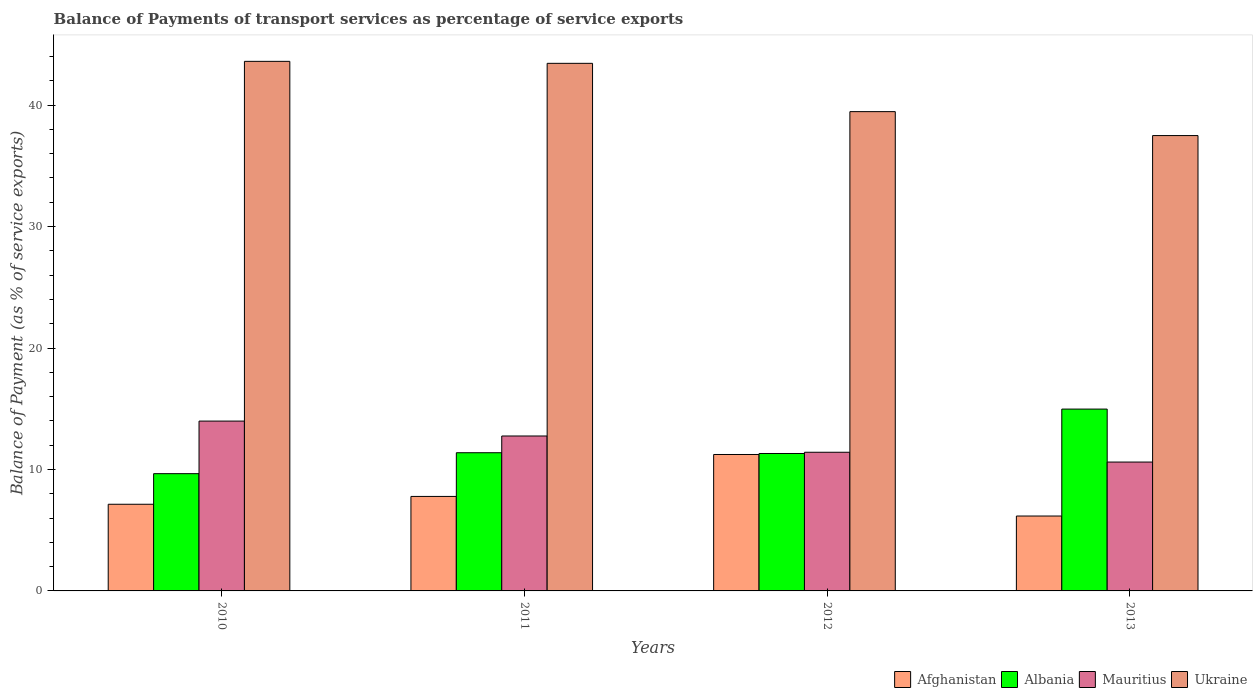How many groups of bars are there?
Offer a terse response. 4. How many bars are there on the 4th tick from the right?
Ensure brevity in your answer.  4. In how many cases, is the number of bars for a given year not equal to the number of legend labels?
Your answer should be compact. 0. What is the balance of payments of transport services in Ukraine in 2011?
Your answer should be compact. 43.44. Across all years, what is the maximum balance of payments of transport services in Mauritius?
Provide a short and direct response. 13.98. Across all years, what is the minimum balance of payments of transport services in Ukraine?
Provide a succinct answer. 37.49. In which year was the balance of payments of transport services in Mauritius minimum?
Give a very brief answer. 2013. What is the total balance of payments of transport services in Afghanistan in the graph?
Your response must be concise. 32.32. What is the difference between the balance of payments of transport services in Mauritius in 2010 and that in 2013?
Offer a very short reply. 3.37. What is the difference between the balance of payments of transport services in Afghanistan in 2010 and the balance of payments of transport services in Ukraine in 2012?
Offer a very short reply. -32.33. What is the average balance of payments of transport services in Mauritius per year?
Provide a succinct answer. 12.19. In the year 2011, what is the difference between the balance of payments of transport services in Albania and balance of payments of transport services in Mauritius?
Keep it short and to the point. -1.38. What is the ratio of the balance of payments of transport services in Afghanistan in 2011 to that in 2013?
Give a very brief answer. 1.26. Is the balance of payments of transport services in Afghanistan in 2010 less than that in 2012?
Offer a very short reply. Yes. What is the difference between the highest and the second highest balance of payments of transport services in Afghanistan?
Provide a succinct answer. 3.45. What is the difference between the highest and the lowest balance of payments of transport services in Albania?
Your answer should be very brief. 5.32. In how many years, is the balance of payments of transport services in Afghanistan greater than the average balance of payments of transport services in Afghanistan taken over all years?
Provide a short and direct response. 1. Is it the case that in every year, the sum of the balance of payments of transport services in Mauritius and balance of payments of transport services in Ukraine is greater than the sum of balance of payments of transport services in Afghanistan and balance of payments of transport services in Albania?
Make the answer very short. Yes. What does the 3rd bar from the left in 2012 represents?
Offer a very short reply. Mauritius. What does the 1st bar from the right in 2010 represents?
Your answer should be compact. Ukraine. How many bars are there?
Keep it short and to the point. 16. Are all the bars in the graph horizontal?
Ensure brevity in your answer.  No. How many years are there in the graph?
Your answer should be very brief. 4. Does the graph contain any zero values?
Offer a terse response. No. Where does the legend appear in the graph?
Your response must be concise. Bottom right. How many legend labels are there?
Ensure brevity in your answer.  4. How are the legend labels stacked?
Your response must be concise. Horizontal. What is the title of the graph?
Provide a succinct answer. Balance of Payments of transport services as percentage of service exports. What is the label or title of the Y-axis?
Your answer should be very brief. Balance of Payment (as % of service exports). What is the Balance of Payment (as % of service exports) of Afghanistan in 2010?
Your response must be concise. 7.14. What is the Balance of Payment (as % of service exports) in Albania in 2010?
Offer a terse response. 9.65. What is the Balance of Payment (as % of service exports) of Mauritius in 2010?
Offer a very short reply. 13.98. What is the Balance of Payment (as % of service exports) of Ukraine in 2010?
Offer a very short reply. 43.6. What is the Balance of Payment (as % of service exports) of Afghanistan in 2011?
Offer a very short reply. 7.78. What is the Balance of Payment (as % of service exports) of Albania in 2011?
Provide a short and direct response. 11.38. What is the Balance of Payment (as % of service exports) of Mauritius in 2011?
Ensure brevity in your answer.  12.76. What is the Balance of Payment (as % of service exports) in Ukraine in 2011?
Keep it short and to the point. 43.44. What is the Balance of Payment (as % of service exports) in Afghanistan in 2012?
Ensure brevity in your answer.  11.23. What is the Balance of Payment (as % of service exports) of Albania in 2012?
Ensure brevity in your answer.  11.31. What is the Balance of Payment (as % of service exports) in Mauritius in 2012?
Keep it short and to the point. 11.42. What is the Balance of Payment (as % of service exports) in Ukraine in 2012?
Provide a succinct answer. 39.46. What is the Balance of Payment (as % of service exports) of Afghanistan in 2013?
Give a very brief answer. 6.17. What is the Balance of Payment (as % of service exports) of Albania in 2013?
Provide a short and direct response. 14.97. What is the Balance of Payment (as % of service exports) of Mauritius in 2013?
Offer a very short reply. 10.61. What is the Balance of Payment (as % of service exports) of Ukraine in 2013?
Make the answer very short. 37.49. Across all years, what is the maximum Balance of Payment (as % of service exports) in Afghanistan?
Provide a succinct answer. 11.23. Across all years, what is the maximum Balance of Payment (as % of service exports) of Albania?
Keep it short and to the point. 14.97. Across all years, what is the maximum Balance of Payment (as % of service exports) in Mauritius?
Offer a terse response. 13.98. Across all years, what is the maximum Balance of Payment (as % of service exports) of Ukraine?
Offer a terse response. 43.6. Across all years, what is the minimum Balance of Payment (as % of service exports) of Afghanistan?
Offer a terse response. 6.17. Across all years, what is the minimum Balance of Payment (as % of service exports) of Albania?
Offer a terse response. 9.65. Across all years, what is the minimum Balance of Payment (as % of service exports) of Mauritius?
Offer a very short reply. 10.61. Across all years, what is the minimum Balance of Payment (as % of service exports) of Ukraine?
Keep it short and to the point. 37.49. What is the total Balance of Payment (as % of service exports) in Afghanistan in the graph?
Your response must be concise. 32.32. What is the total Balance of Payment (as % of service exports) of Albania in the graph?
Offer a very short reply. 47.32. What is the total Balance of Payment (as % of service exports) of Mauritius in the graph?
Give a very brief answer. 48.77. What is the total Balance of Payment (as % of service exports) of Ukraine in the graph?
Make the answer very short. 164. What is the difference between the Balance of Payment (as % of service exports) of Afghanistan in 2010 and that in 2011?
Offer a terse response. -0.64. What is the difference between the Balance of Payment (as % of service exports) in Albania in 2010 and that in 2011?
Ensure brevity in your answer.  -1.72. What is the difference between the Balance of Payment (as % of service exports) of Mauritius in 2010 and that in 2011?
Your answer should be compact. 1.23. What is the difference between the Balance of Payment (as % of service exports) of Ukraine in 2010 and that in 2011?
Give a very brief answer. 0.16. What is the difference between the Balance of Payment (as % of service exports) in Afghanistan in 2010 and that in 2012?
Provide a short and direct response. -4.1. What is the difference between the Balance of Payment (as % of service exports) in Albania in 2010 and that in 2012?
Provide a succinct answer. -1.66. What is the difference between the Balance of Payment (as % of service exports) of Mauritius in 2010 and that in 2012?
Provide a short and direct response. 2.57. What is the difference between the Balance of Payment (as % of service exports) in Ukraine in 2010 and that in 2012?
Provide a short and direct response. 4.14. What is the difference between the Balance of Payment (as % of service exports) in Afghanistan in 2010 and that in 2013?
Your answer should be compact. 0.97. What is the difference between the Balance of Payment (as % of service exports) in Albania in 2010 and that in 2013?
Your response must be concise. -5.32. What is the difference between the Balance of Payment (as % of service exports) in Mauritius in 2010 and that in 2013?
Give a very brief answer. 3.37. What is the difference between the Balance of Payment (as % of service exports) of Ukraine in 2010 and that in 2013?
Make the answer very short. 6.11. What is the difference between the Balance of Payment (as % of service exports) in Afghanistan in 2011 and that in 2012?
Offer a very short reply. -3.45. What is the difference between the Balance of Payment (as % of service exports) of Albania in 2011 and that in 2012?
Your answer should be very brief. 0.06. What is the difference between the Balance of Payment (as % of service exports) of Mauritius in 2011 and that in 2012?
Your answer should be compact. 1.34. What is the difference between the Balance of Payment (as % of service exports) in Ukraine in 2011 and that in 2012?
Offer a very short reply. 3.98. What is the difference between the Balance of Payment (as % of service exports) in Afghanistan in 2011 and that in 2013?
Keep it short and to the point. 1.61. What is the difference between the Balance of Payment (as % of service exports) in Albania in 2011 and that in 2013?
Your answer should be compact. -3.59. What is the difference between the Balance of Payment (as % of service exports) of Mauritius in 2011 and that in 2013?
Provide a succinct answer. 2.15. What is the difference between the Balance of Payment (as % of service exports) in Ukraine in 2011 and that in 2013?
Provide a short and direct response. 5.95. What is the difference between the Balance of Payment (as % of service exports) of Afghanistan in 2012 and that in 2013?
Keep it short and to the point. 5.07. What is the difference between the Balance of Payment (as % of service exports) of Albania in 2012 and that in 2013?
Your answer should be compact. -3.66. What is the difference between the Balance of Payment (as % of service exports) in Mauritius in 2012 and that in 2013?
Provide a short and direct response. 0.81. What is the difference between the Balance of Payment (as % of service exports) of Ukraine in 2012 and that in 2013?
Offer a terse response. 1.97. What is the difference between the Balance of Payment (as % of service exports) of Afghanistan in 2010 and the Balance of Payment (as % of service exports) of Albania in 2011?
Offer a very short reply. -4.24. What is the difference between the Balance of Payment (as % of service exports) in Afghanistan in 2010 and the Balance of Payment (as % of service exports) in Mauritius in 2011?
Make the answer very short. -5.62. What is the difference between the Balance of Payment (as % of service exports) of Afghanistan in 2010 and the Balance of Payment (as % of service exports) of Ukraine in 2011?
Make the answer very short. -36.3. What is the difference between the Balance of Payment (as % of service exports) in Albania in 2010 and the Balance of Payment (as % of service exports) in Mauritius in 2011?
Your answer should be compact. -3.1. What is the difference between the Balance of Payment (as % of service exports) of Albania in 2010 and the Balance of Payment (as % of service exports) of Ukraine in 2011?
Your response must be concise. -33.78. What is the difference between the Balance of Payment (as % of service exports) of Mauritius in 2010 and the Balance of Payment (as % of service exports) of Ukraine in 2011?
Your answer should be compact. -29.46. What is the difference between the Balance of Payment (as % of service exports) in Afghanistan in 2010 and the Balance of Payment (as % of service exports) in Albania in 2012?
Provide a succinct answer. -4.18. What is the difference between the Balance of Payment (as % of service exports) in Afghanistan in 2010 and the Balance of Payment (as % of service exports) in Mauritius in 2012?
Your answer should be compact. -4.28. What is the difference between the Balance of Payment (as % of service exports) in Afghanistan in 2010 and the Balance of Payment (as % of service exports) in Ukraine in 2012?
Your answer should be compact. -32.33. What is the difference between the Balance of Payment (as % of service exports) in Albania in 2010 and the Balance of Payment (as % of service exports) in Mauritius in 2012?
Offer a terse response. -1.76. What is the difference between the Balance of Payment (as % of service exports) of Albania in 2010 and the Balance of Payment (as % of service exports) of Ukraine in 2012?
Keep it short and to the point. -29.81. What is the difference between the Balance of Payment (as % of service exports) of Mauritius in 2010 and the Balance of Payment (as % of service exports) of Ukraine in 2012?
Keep it short and to the point. -25.48. What is the difference between the Balance of Payment (as % of service exports) of Afghanistan in 2010 and the Balance of Payment (as % of service exports) of Albania in 2013?
Provide a succinct answer. -7.84. What is the difference between the Balance of Payment (as % of service exports) of Afghanistan in 2010 and the Balance of Payment (as % of service exports) of Mauritius in 2013?
Ensure brevity in your answer.  -3.47. What is the difference between the Balance of Payment (as % of service exports) of Afghanistan in 2010 and the Balance of Payment (as % of service exports) of Ukraine in 2013?
Give a very brief answer. -30.36. What is the difference between the Balance of Payment (as % of service exports) in Albania in 2010 and the Balance of Payment (as % of service exports) in Mauritius in 2013?
Your answer should be very brief. -0.96. What is the difference between the Balance of Payment (as % of service exports) in Albania in 2010 and the Balance of Payment (as % of service exports) in Ukraine in 2013?
Give a very brief answer. -27.84. What is the difference between the Balance of Payment (as % of service exports) in Mauritius in 2010 and the Balance of Payment (as % of service exports) in Ukraine in 2013?
Your answer should be compact. -23.51. What is the difference between the Balance of Payment (as % of service exports) of Afghanistan in 2011 and the Balance of Payment (as % of service exports) of Albania in 2012?
Your response must be concise. -3.54. What is the difference between the Balance of Payment (as % of service exports) in Afghanistan in 2011 and the Balance of Payment (as % of service exports) in Mauritius in 2012?
Provide a short and direct response. -3.64. What is the difference between the Balance of Payment (as % of service exports) of Afghanistan in 2011 and the Balance of Payment (as % of service exports) of Ukraine in 2012?
Your answer should be very brief. -31.68. What is the difference between the Balance of Payment (as % of service exports) of Albania in 2011 and the Balance of Payment (as % of service exports) of Mauritius in 2012?
Give a very brief answer. -0.04. What is the difference between the Balance of Payment (as % of service exports) of Albania in 2011 and the Balance of Payment (as % of service exports) of Ukraine in 2012?
Ensure brevity in your answer.  -28.08. What is the difference between the Balance of Payment (as % of service exports) of Mauritius in 2011 and the Balance of Payment (as % of service exports) of Ukraine in 2012?
Make the answer very short. -26.71. What is the difference between the Balance of Payment (as % of service exports) in Afghanistan in 2011 and the Balance of Payment (as % of service exports) in Albania in 2013?
Offer a terse response. -7.19. What is the difference between the Balance of Payment (as % of service exports) in Afghanistan in 2011 and the Balance of Payment (as % of service exports) in Mauritius in 2013?
Provide a short and direct response. -2.83. What is the difference between the Balance of Payment (as % of service exports) of Afghanistan in 2011 and the Balance of Payment (as % of service exports) of Ukraine in 2013?
Provide a short and direct response. -29.71. What is the difference between the Balance of Payment (as % of service exports) in Albania in 2011 and the Balance of Payment (as % of service exports) in Mauritius in 2013?
Provide a short and direct response. 0.77. What is the difference between the Balance of Payment (as % of service exports) of Albania in 2011 and the Balance of Payment (as % of service exports) of Ukraine in 2013?
Offer a terse response. -26.11. What is the difference between the Balance of Payment (as % of service exports) in Mauritius in 2011 and the Balance of Payment (as % of service exports) in Ukraine in 2013?
Give a very brief answer. -24.74. What is the difference between the Balance of Payment (as % of service exports) in Afghanistan in 2012 and the Balance of Payment (as % of service exports) in Albania in 2013?
Provide a short and direct response. -3.74. What is the difference between the Balance of Payment (as % of service exports) in Afghanistan in 2012 and the Balance of Payment (as % of service exports) in Mauritius in 2013?
Offer a very short reply. 0.62. What is the difference between the Balance of Payment (as % of service exports) in Afghanistan in 2012 and the Balance of Payment (as % of service exports) in Ukraine in 2013?
Ensure brevity in your answer.  -26.26. What is the difference between the Balance of Payment (as % of service exports) of Albania in 2012 and the Balance of Payment (as % of service exports) of Mauritius in 2013?
Your answer should be very brief. 0.7. What is the difference between the Balance of Payment (as % of service exports) of Albania in 2012 and the Balance of Payment (as % of service exports) of Ukraine in 2013?
Give a very brief answer. -26.18. What is the difference between the Balance of Payment (as % of service exports) in Mauritius in 2012 and the Balance of Payment (as % of service exports) in Ukraine in 2013?
Provide a succinct answer. -26.08. What is the average Balance of Payment (as % of service exports) of Afghanistan per year?
Provide a succinct answer. 8.08. What is the average Balance of Payment (as % of service exports) in Albania per year?
Keep it short and to the point. 11.83. What is the average Balance of Payment (as % of service exports) of Mauritius per year?
Keep it short and to the point. 12.19. What is the average Balance of Payment (as % of service exports) of Ukraine per year?
Your response must be concise. 41. In the year 2010, what is the difference between the Balance of Payment (as % of service exports) in Afghanistan and Balance of Payment (as % of service exports) in Albania?
Your answer should be compact. -2.52. In the year 2010, what is the difference between the Balance of Payment (as % of service exports) of Afghanistan and Balance of Payment (as % of service exports) of Mauritius?
Provide a succinct answer. -6.85. In the year 2010, what is the difference between the Balance of Payment (as % of service exports) of Afghanistan and Balance of Payment (as % of service exports) of Ukraine?
Give a very brief answer. -36.47. In the year 2010, what is the difference between the Balance of Payment (as % of service exports) of Albania and Balance of Payment (as % of service exports) of Mauritius?
Your response must be concise. -4.33. In the year 2010, what is the difference between the Balance of Payment (as % of service exports) of Albania and Balance of Payment (as % of service exports) of Ukraine?
Offer a terse response. -33.95. In the year 2010, what is the difference between the Balance of Payment (as % of service exports) in Mauritius and Balance of Payment (as % of service exports) in Ukraine?
Provide a succinct answer. -29.62. In the year 2011, what is the difference between the Balance of Payment (as % of service exports) in Afghanistan and Balance of Payment (as % of service exports) in Albania?
Your answer should be compact. -3.6. In the year 2011, what is the difference between the Balance of Payment (as % of service exports) of Afghanistan and Balance of Payment (as % of service exports) of Mauritius?
Provide a short and direct response. -4.98. In the year 2011, what is the difference between the Balance of Payment (as % of service exports) in Afghanistan and Balance of Payment (as % of service exports) in Ukraine?
Your response must be concise. -35.66. In the year 2011, what is the difference between the Balance of Payment (as % of service exports) in Albania and Balance of Payment (as % of service exports) in Mauritius?
Keep it short and to the point. -1.38. In the year 2011, what is the difference between the Balance of Payment (as % of service exports) of Albania and Balance of Payment (as % of service exports) of Ukraine?
Your answer should be very brief. -32.06. In the year 2011, what is the difference between the Balance of Payment (as % of service exports) of Mauritius and Balance of Payment (as % of service exports) of Ukraine?
Keep it short and to the point. -30.68. In the year 2012, what is the difference between the Balance of Payment (as % of service exports) in Afghanistan and Balance of Payment (as % of service exports) in Albania?
Offer a very short reply. -0.08. In the year 2012, what is the difference between the Balance of Payment (as % of service exports) in Afghanistan and Balance of Payment (as % of service exports) in Mauritius?
Your answer should be compact. -0.18. In the year 2012, what is the difference between the Balance of Payment (as % of service exports) in Afghanistan and Balance of Payment (as % of service exports) in Ukraine?
Offer a terse response. -28.23. In the year 2012, what is the difference between the Balance of Payment (as % of service exports) in Albania and Balance of Payment (as % of service exports) in Mauritius?
Your response must be concise. -0.1. In the year 2012, what is the difference between the Balance of Payment (as % of service exports) in Albania and Balance of Payment (as % of service exports) in Ukraine?
Give a very brief answer. -28.15. In the year 2012, what is the difference between the Balance of Payment (as % of service exports) in Mauritius and Balance of Payment (as % of service exports) in Ukraine?
Provide a short and direct response. -28.05. In the year 2013, what is the difference between the Balance of Payment (as % of service exports) in Afghanistan and Balance of Payment (as % of service exports) in Albania?
Your answer should be compact. -8.8. In the year 2013, what is the difference between the Balance of Payment (as % of service exports) of Afghanistan and Balance of Payment (as % of service exports) of Mauritius?
Make the answer very short. -4.44. In the year 2013, what is the difference between the Balance of Payment (as % of service exports) in Afghanistan and Balance of Payment (as % of service exports) in Ukraine?
Your answer should be compact. -31.32. In the year 2013, what is the difference between the Balance of Payment (as % of service exports) of Albania and Balance of Payment (as % of service exports) of Mauritius?
Keep it short and to the point. 4.36. In the year 2013, what is the difference between the Balance of Payment (as % of service exports) of Albania and Balance of Payment (as % of service exports) of Ukraine?
Offer a very short reply. -22.52. In the year 2013, what is the difference between the Balance of Payment (as % of service exports) of Mauritius and Balance of Payment (as % of service exports) of Ukraine?
Provide a short and direct response. -26.88. What is the ratio of the Balance of Payment (as % of service exports) of Afghanistan in 2010 to that in 2011?
Provide a succinct answer. 0.92. What is the ratio of the Balance of Payment (as % of service exports) of Albania in 2010 to that in 2011?
Offer a terse response. 0.85. What is the ratio of the Balance of Payment (as % of service exports) of Mauritius in 2010 to that in 2011?
Make the answer very short. 1.1. What is the ratio of the Balance of Payment (as % of service exports) in Ukraine in 2010 to that in 2011?
Ensure brevity in your answer.  1. What is the ratio of the Balance of Payment (as % of service exports) in Afghanistan in 2010 to that in 2012?
Offer a terse response. 0.64. What is the ratio of the Balance of Payment (as % of service exports) of Albania in 2010 to that in 2012?
Provide a short and direct response. 0.85. What is the ratio of the Balance of Payment (as % of service exports) in Mauritius in 2010 to that in 2012?
Provide a short and direct response. 1.22. What is the ratio of the Balance of Payment (as % of service exports) of Ukraine in 2010 to that in 2012?
Offer a terse response. 1.1. What is the ratio of the Balance of Payment (as % of service exports) of Afghanistan in 2010 to that in 2013?
Ensure brevity in your answer.  1.16. What is the ratio of the Balance of Payment (as % of service exports) in Albania in 2010 to that in 2013?
Offer a very short reply. 0.64. What is the ratio of the Balance of Payment (as % of service exports) in Mauritius in 2010 to that in 2013?
Ensure brevity in your answer.  1.32. What is the ratio of the Balance of Payment (as % of service exports) of Ukraine in 2010 to that in 2013?
Keep it short and to the point. 1.16. What is the ratio of the Balance of Payment (as % of service exports) of Afghanistan in 2011 to that in 2012?
Offer a very short reply. 0.69. What is the ratio of the Balance of Payment (as % of service exports) of Albania in 2011 to that in 2012?
Your answer should be compact. 1.01. What is the ratio of the Balance of Payment (as % of service exports) of Mauritius in 2011 to that in 2012?
Offer a very short reply. 1.12. What is the ratio of the Balance of Payment (as % of service exports) in Ukraine in 2011 to that in 2012?
Give a very brief answer. 1.1. What is the ratio of the Balance of Payment (as % of service exports) in Afghanistan in 2011 to that in 2013?
Provide a succinct answer. 1.26. What is the ratio of the Balance of Payment (as % of service exports) of Albania in 2011 to that in 2013?
Give a very brief answer. 0.76. What is the ratio of the Balance of Payment (as % of service exports) of Mauritius in 2011 to that in 2013?
Your answer should be very brief. 1.2. What is the ratio of the Balance of Payment (as % of service exports) in Ukraine in 2011 to that in 2013?
Keep it short and to the point. 1.16. What is the ratio of the Balance of Payment (as % of service exports) in Afghanistan in 2012 to that in 2013?
Your response must be concise. 1.82. What is the ratio of the Balance of Payment (as % of service exports) of Albania in 2012 to that in 2013?
Provide a succinct answer. 0.76. What is the ratio of the Balance of Payment (as % of service exports) of Mauritius in 2012 to that in 2013?
Offer a terse response. 1.08. What is the ratio of the Balance of Payment (as % of service exports) in Ukraine in 2012 to that in 2013?
Keep it short and to the point. 1.05. What is the difference between the highest and the second highest Balance of Payment (as % of service exports) in Afghanistan?
Your answer should be compact. 3.45. What is the difference between the highest and the second highest Balance of Payment (as % of service exports) in Albania?
Give a very brief answer. 3.59. What is the difference between the highest and the second highest Balance of Payment (as % of service exports) in Mauritius?
Offer a terse response. 1.23. What is the difference between the highest and the second highest Balance of Payment (as % of service exports) in Ukraine?
Make the answer very short. 0.16. What is the difference between the highest and the lowest Balance of Payment (as % of service exports) in Afghanistan?
Ensure brevity in your answer.  5.07. What is the difference between the highest and the lowest Balance of Payment (as % of service exports) of Albania?
Keep it short and to the point. 5.32. What is the difference between the highest and the lowest Balance of Payment (as % of service exports) in Mauritius?
Offer a very short reply. 3.37. What is the difference between the highest and the lowest Balance of Payment (as % of service exports) of Ukraine?
Provide a short and direct response. 6.11. 